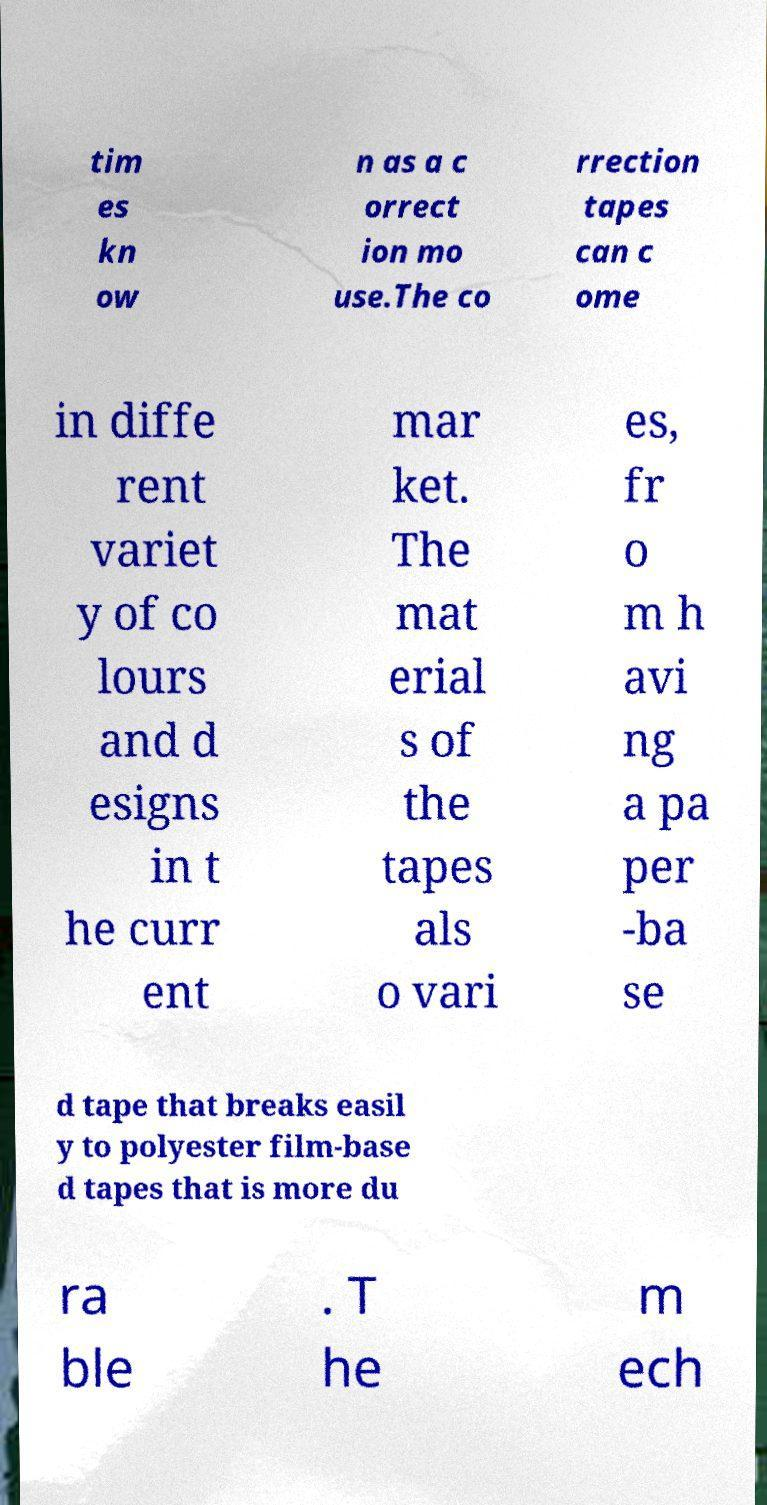Could you extract and type out the text from this image? tim es kn ow n as a c orrect ion mo use.The co rrection tapes can c ome in diffe rent variet y of co lours and d esigns in t he curr ent mar ket. The mat erial s of the tapes als o vari es, fr o m h avi ng a pa per -ba se d tape that breaks easil y to polyester film-base d tapes that is more du ra ble . T he m ech 